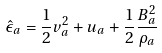Convert formula to latex. <formula><loc_0><loc_0><loc_500><loc_500>\hat { \epsilon } _ { a } = \frac { 1 } { 2 } v _ { a } ^ { 2 } + u _ { a } + \frac { 1 } { 2 } \frac { B _ { a } ^ { 2 } } { \rho _ { a } }</formula> 